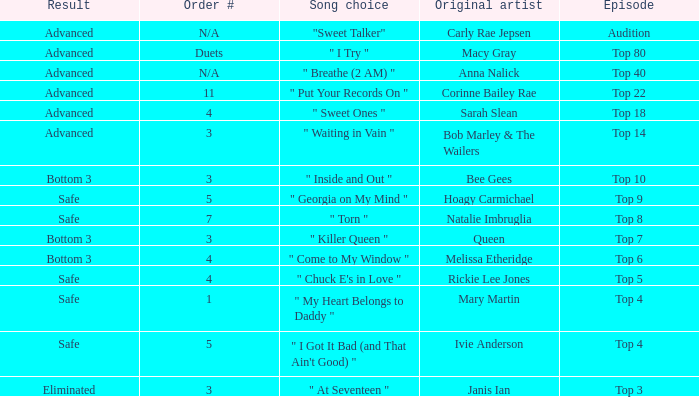Which one of the songs was originally performed by Rickie Lee Jones? " Chuck E's in Love ". 